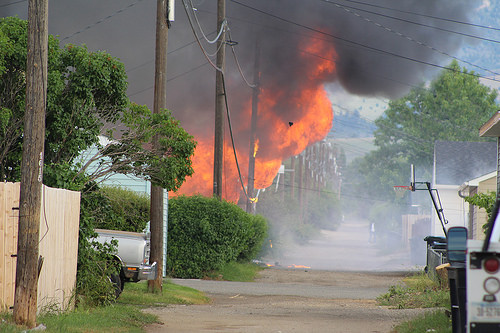<image>
Is there a tree behind the fire? No. The tree is not behind the fire. From this viewpoint, the tree appears to be positioned elsewhere in the scene. 